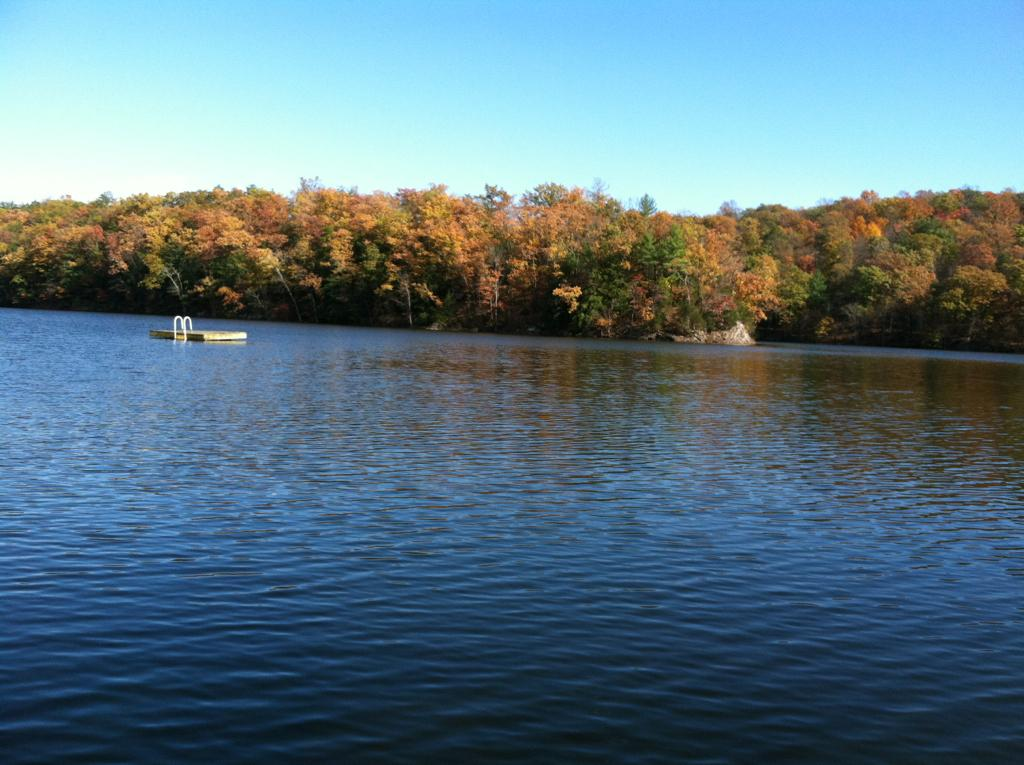What is located in the water in the image? There is an object in the water in the image. What can be seen in the background of the image? There are trees visible in the background. What is the color of the sky in the image? The sky is blue in color. What type of elbow is being taught in the image? There is no elbow or teaching activity present in the image. 